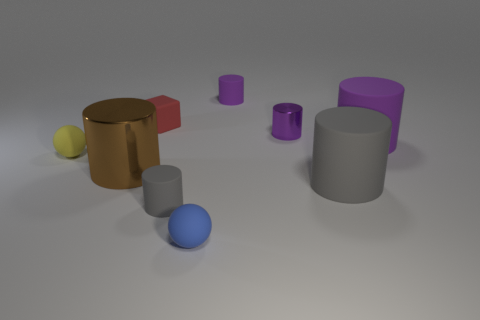The purple metallic thing that is the same shape as the large gray object is what size?
Your response must be concise. Small. What number of other objects are the same material as the yellow object?
Make the answer very short. 6. There is a purple rubber object that is in front of the red cube; does it have the same shape as the large rubber thing that is in front of the big purple rubber thing?
Keep it short and to the point. Yes. Do the small blue ball and the brown cylinder have the same material?
Provide a short and direct response. No. There is a purple cylinder that is left of the metal thing behind the tiny thing on the left side of the brown metallic cylinder; what is its size?
Ensure brevity in your answer.  Small. What number of other objects are there of the same color as the rubber cube?
Your answer should be compact. 0. There is a yellow object that is the same size as the blue ball; what is its shape?
Give a very brief answer. Sphere. How many large objects are either rubber spheres or red metallic spheres?
Your answer should be very brief. 0. There is a gray thing that is to the right of the tiny matte cylinder that is left of the blue object; is there a rubber object in front of it?
Offer a terse response. Yes. Are there any yellow rubber things of the same size as the rubber cube?
Keep it short and to the point. Yes. 